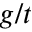<formula> <loc_0><loc_0><loc_500><loc_500>g / t</formula> 